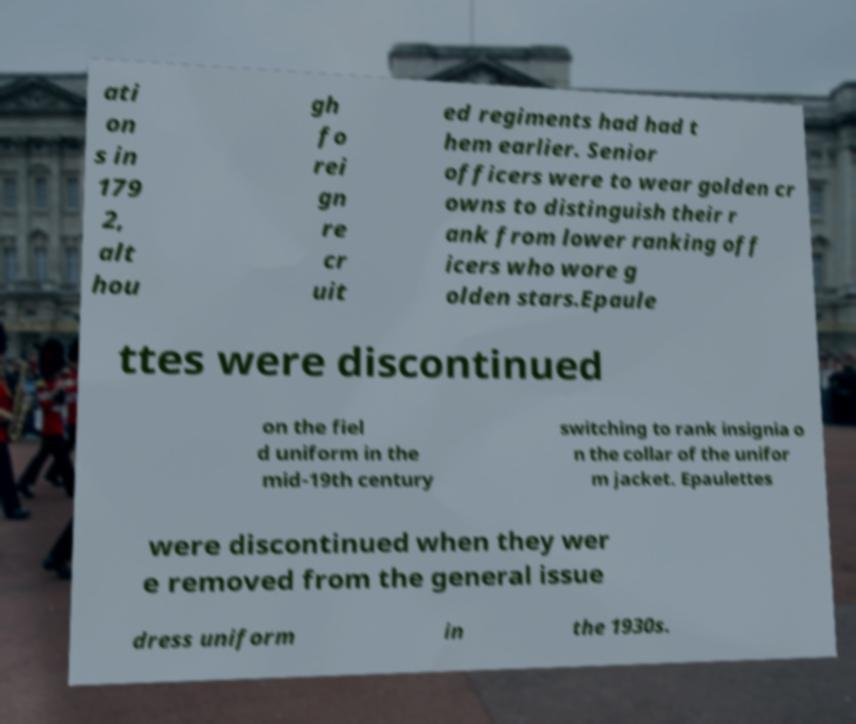Could you extract and type out the text from this image? ati on s in 179 2, alt hou gh fo rei gn re cr uit ed regiments had had t hem earlier. Senior officers were to wear golden cr owns to distinguish their r ank from lower ranking off icers who wore g olden stars.Epaule ttes were discontinued on the fiel d uniform in the mid-19th century switching to rank insignia o n the collar of the unifor m jacket. Epaulettes were discontinued when they wer e removed from the general issue dress uniform in the 1930s. 